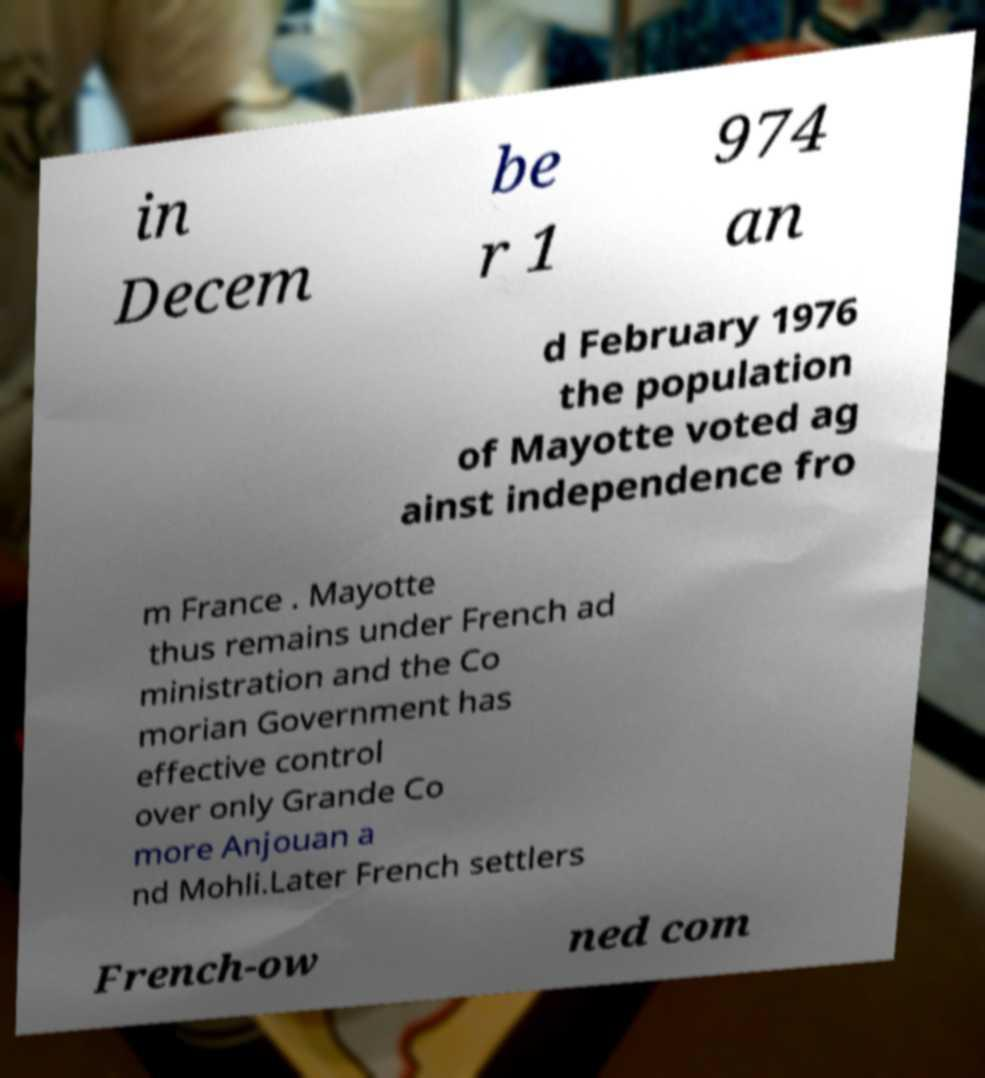What messages or text are displayed in this image? I need them in a readable, typed format. in Decem be r 1 974 an d February 1976 the population of Mayotte voted ag ainst independence fro m France . Mayotte thus remains under French ad ministration and the Co morian Government has effective control over only Grande Co more Anjouan a nd Mohli.Later French settlers French-ow ned com 